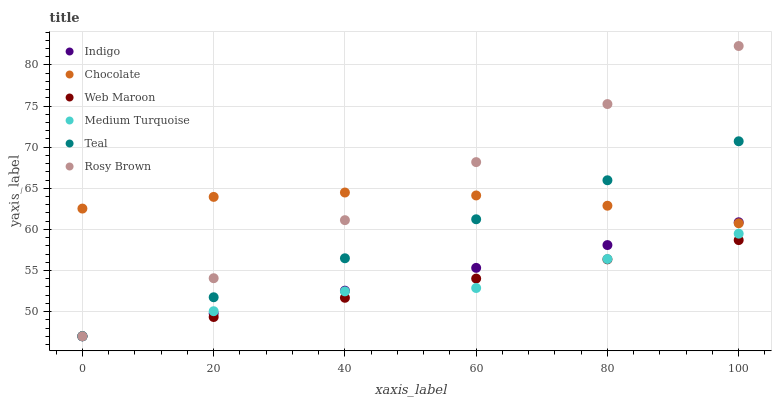Does Web Maroon have the minimum area under the curve?
Answer yes or no. Yes. Does Rosy Brown have the maximum area under the curve?
Answer yes or no. Yes. Does Medium Turquoise have the minimum area under the curve?
Answer yes or no. No. Does Medium Turquoise have the maximum area under the curve?
Answer yes or no. No. Is Web Maroon the smoothest?
Answer yes or no. Yes. Is Medium Turquoise the roughest?
Answer yes or no. Yes. Is Rosy Brown the smoothest?
Answer yes or no. No. Is Rosy Brown the roughest?
Answer yes or no. No. Does Indigo have the lowest value?
Answer yes or no. Yes. Does Chocolate have the lowest value?
Answer yes or no. No. Does Rosy Brown have the highest value?
Answer yes or no. Yes. Does Medium Turquoise have the highest value?
Answer yes or no. No. Is Web Maroon less than Chocolate?
Answer yes or no. Yes. Is Chocolate greater than Web Maroon?
Answer yes or no. Yes. Does Chocolate intersect Rosy Brown?
Answer yes or no. Yes. Is Chocolate less than Rosy Brown?
Answer yes or no. No. Is Chocolate greater than Rosy Brown?
Answer yes or no. No. Does Web Maroon intersect Chocolate?
Answer yes or no. No. 